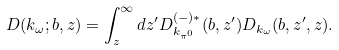Convert formula to latex. <formula><loc_0><loc_0><loc_500><loc_500>D ( { k } _ { \omega } ; { b } , z ) = \int ^ { \infty } _ { z } d z ^ { \prime } D ^ { ( - ) * } _ { k _ { \pi ^ { 0 } } } ( { b } , z ^ { \prime } ) D _ { k _ { \omega } } ( { b } , z ^ { \prime } , z ) .</formula> 